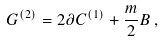<formula> <loc_0><loc_0><loc_500><loc_500>G ^ { ( 2 ) } = 2 \partial C ^ { ( 1 ) } + { \frac { m } { 2 } } B \, ,</formula> 